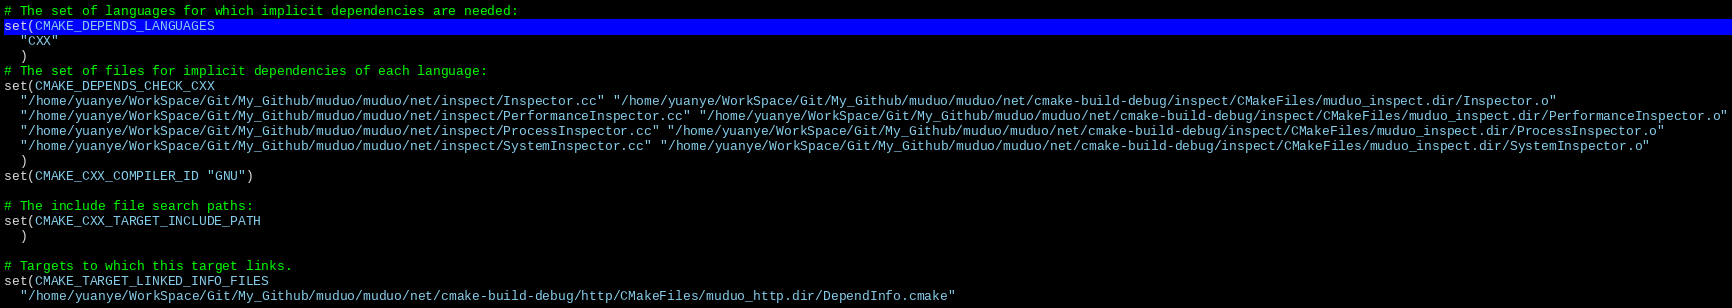<code> <loc_0><loc_0><loc_500><loc_500><_CMake_># The set of languages for which implicit dependencies are needed:
set(CMAKE_DEPENDS_LANGUAGES
  "CXX"
  )
# The set of files for implicit dependencies of each language:
set(CMAKE_DEPENDS_CHECK_CXX
  "/home/yuanye/WorkSpace/Git/My_Github/muduo/muduo/net/inspect/Inspector.cc" "/home/yuanye/WorkSpace/Git/My_Github/muduo/muduo/net/cmake-build-debug/inspect/CMakeFiles/muduo_inspect.dir/Inspector.o"
  "/home/yuanye/WorkSpace/Git/My_Github/muduo/muduo/net/inspect/PerformanceInspector.cc" "/home/yuanye/WorkSpace/Git/My_Github/muduo/muduo/net/cmake-build-debug/inspect/CMakeFiles/muduo_inspect.dir/PerformanceInspector.o"
  "/home/yuanye/WorkSpace/Git/My_Github/muduo/muduo/net/inspect/ProcessInspector.cc" "/home/yuanye/WorkSpace/Git/My_Github/muduo/muduo/net/cmake-build-debug/inspect/CMakeFiles/muduo_inspect.dir/ProcessInspector.o"
  "/home/yuanye/WorkSpace/Git/My_Github/muduo/muduo/net/inspect/SystemInspector.cc" "/home/yuanye/WorkSpace/Git/My_Github/muduo/muduo/net/cmake-build-debug/inspect/CMakeFiles/muduo_inspect.dir/SystemInspector.o"
  )
set(CMAKE_CXX_COMPILER_ID "GNU")

# The include file search paths:
set(CMAKE_CXX_TARGET_INCLUDE_PATH
  )

# Targets to which this target links.
set(CMAKE_TARGET_LINKED_INFO_FILES
  "/home/yuanye/WorkSpace/Git/My_Github/muduo/muduo/net/cmake-build-debug/http/CMakeFiles/muduo_http.dir/DependInfo.cmake"</code> 